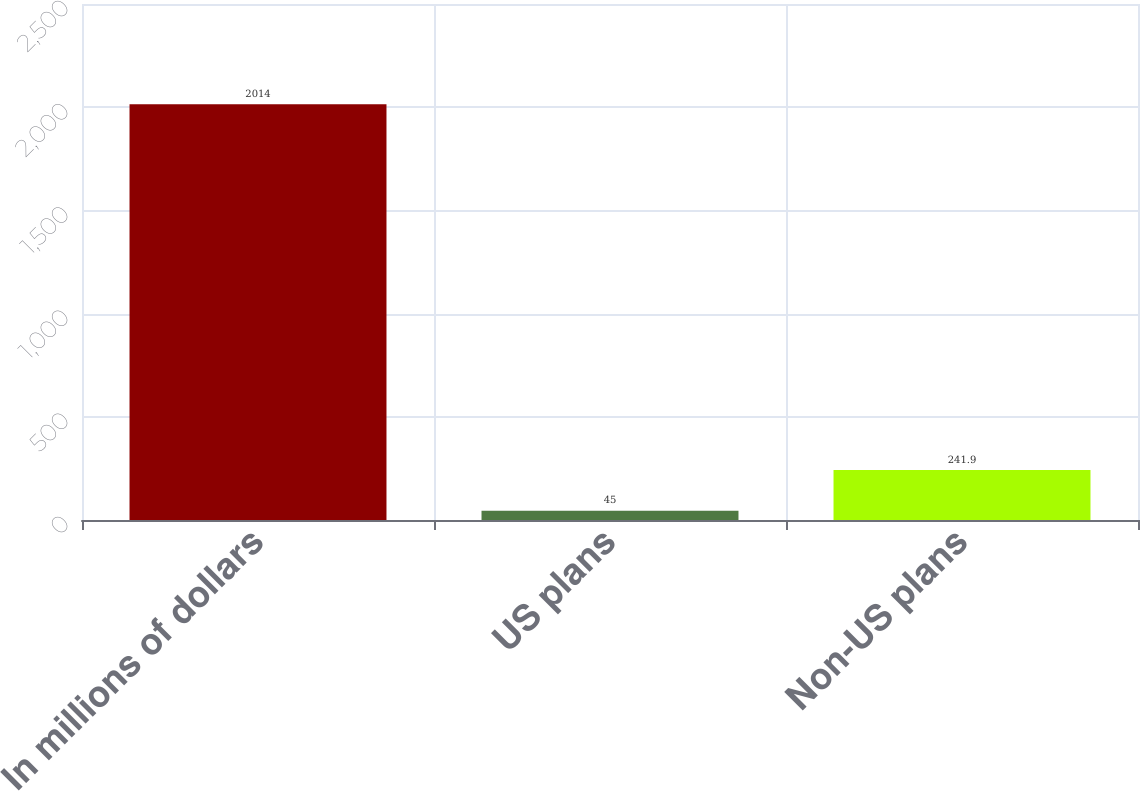Convert chart. <chart><loc_0><loc_0><loc_500><loc_500><bar_chart><fcel>In millions of dollars<fcel>US plans<fcel>Non-US plans<nl><fcel>2014<fcel>45<fcel>241.9<nl></chart> 